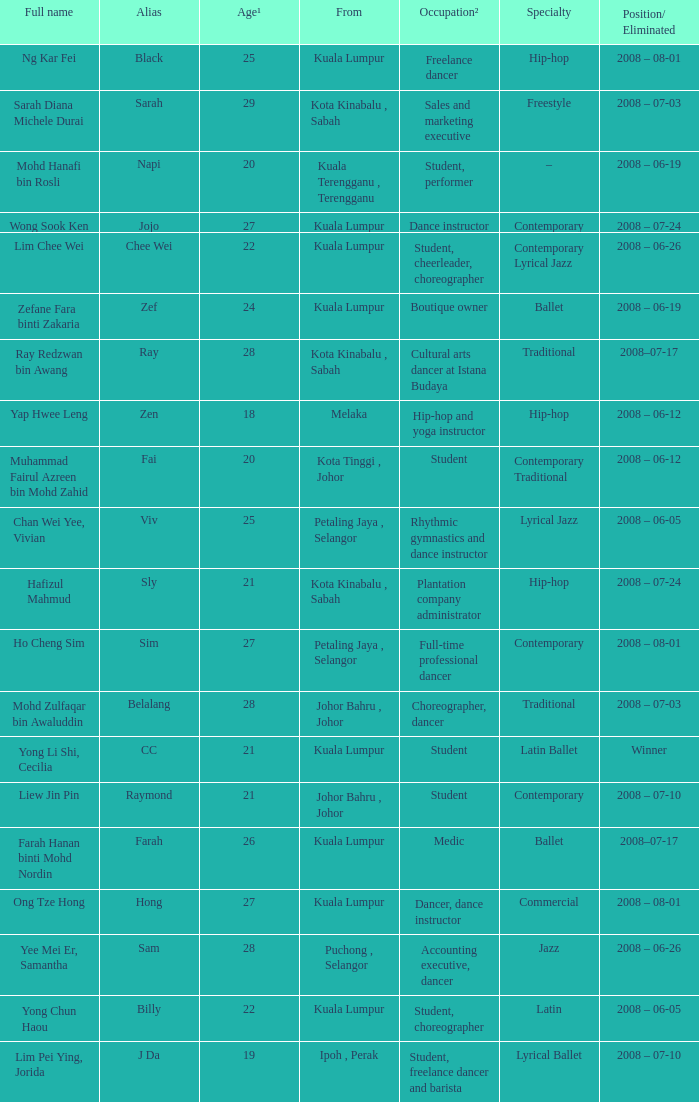Parse the table in full. {'header': ['Full name', 'Alias', 'Age¹', 'From', 'Occupation²', 'Specialty', 'Position/ Eliminated'], 'rows': [['Ng Kar Fei', 'Black', '25', 'Kuala Lumpur', 'Freelance dancer', 'Hip-hop', '2008 – 08-01'], ['Sarah Diana Michele Durai', 'Sarah', '29', 'Kota Kinabalu , Sabah', 'Sales and marketing executive', 'Freestyle', '2008 – 07-03'], ['Mohd Hanafi bin Rosli', 'Napi', '20', 'Kuala Terengganu , Terengganu', 'Student, performer', '–', '2008 – 06-19'], ['Wong Sook Ken', 'Jojo', '27', 'Kuala Lumpur', 'Dance instructor', 'Contemporary', '2008 – 07-24'], ['Lim Chee Wei', 'Chee Wei', '22', 'Kuala Lumpur', 'Student, cheerleader, choreographer', 'Contemporary Lyrical Jazz', '2008 – 06-26'], ['Zefane Fara binti Zakaria', 'Zef', '24', 'Kuala Lumpur', 'Boutique owner', 'Ballet', '2008 – 06-19'], ['Ray Redzwan bin Awang', 'Ray', '28', 'Kota Kinabalu , Sabah', 'Cultural arts dancer at Istana Budaya', 'Traditional', '2008–07-17'], ['Yap Hwee Leng', 'Zen', '18', 'Melaka', 'Hip-hop and yoga instructor', 'Hip-hop', '2008 – 06-12'], ['Muhammad Fairul Azreen bin Mohd Zahid', 'Fai', '20', 'Kota Tinggi , Johor', 'Student', 'Contemporary Traditional', '2008 – 06-12'], ['Chan Wei Yee, Vivian', 'Viv', '25', 'Petaling Jaya , Selangor', 'Rhythmic gymnastics and dance instructor', 'Lyrical Jazz', '2008 – 06-05'], ['Hafizul Mahmud', 'Sly', '21', 'Kota Kinabalu , Sabah', 'Plantation company administrator', 'Hip-hop', '2008 – 07-24'], ['Ho Cheng Sim', 'Sim', '27', 'Petaling Jaya , Selangor', 'Full-time professional dancer', 'Contemporary', '2008 – 08-01'], ['Mohd Zulfaqar bin Awaluddin', 'Belalang', '28', 'Johor Bahru , Johor', 'Choreographer, dancer', 'Traditional', '2008 – 07-03'], ['Yong Li Shi, Cecilia', 'CC', '21', 'Kuala Lumpur', 'Student', 'Latin Ballet', 'Winner'], ['Liew Jin Pin', 'Raymond', '21', 'Johor Bahru , Johor', 'Student', 'Contemporary', '2008 – 07-10'], ['Farah Hanan binti Mohd Nordin', 'Farah', '26', 'Kuala Lumpur', 'Medic', 'Ballet', '2008–07-17'], ['Ong Tze Hong', 'Hong', '27', 'Kuala Lumpur', 'Dancer, dance instructor', 'Commercial', '2008 – 08-01'], ['Yee Mei Er, Samantha', 'Sam', '28', 'Puchong , Selangor', 'Accounting executive, dancer', 'Jazz', '2008 – 06-26'], ['Yong Chun Haou', 'Billy', '22', 'Kuala Lumpur', 'Student, choreographer', 'Latin', '2008 – 06-05'], ['Lim Pei Ying, Jorida', 'J Da', '19', 'Ipoh , Perak', 'Student, freelance dancer and barista', 'Lyrical Ballet', '2008 – 07-10']]} What is the complete name when the individual's age is 20 and their occupation is a student? Muhammad Fairul Azreen bin Mohd Zahid. 